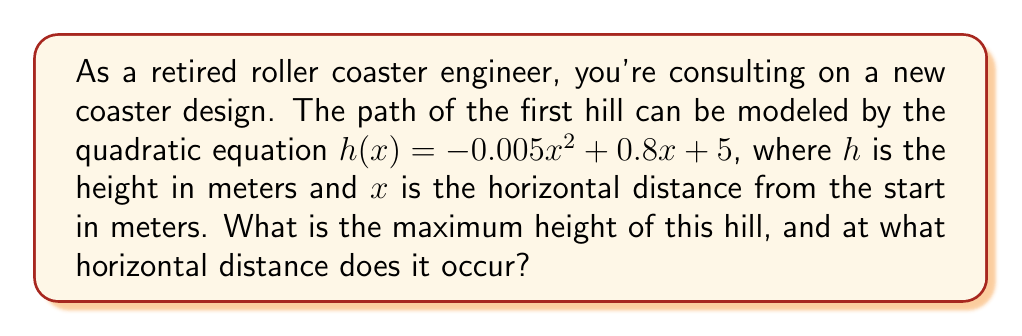Help me with this question. To find the maximum height of the roller coaster hill, we need to follow these steps:

1) The quadratic equation is in the form $h(x) = ax^2 + bx + c$, where:
   $a = -0.005$
   $b = 0.8$
   $c = 5$

2) For a quadratic function, the x-coordinate of the vertex represents the point where the maximum (or minimum) occurs. We can find this using the formula:

   $$x = -\frac{b}{2a}$$

3) Substituting our values:

   $$x = -\frac{0.8}{2(-0.005)} = -\frac{0.8}{-0.01} = 80$$

4) To find the maximum height, we need to calculate $h(80)$:

   $$\begin{align}
   h(80) &= -0.005(80)^2 + 0.8(80) + 5 \\
   &= -0.005(6400) + 64 + 5 \\
   &= -32 + 64 + 5 \\
   &= 37
   \end{align}$$

5) Therefore, the maximum height occurs at a horizontal distance of 80 meters from the start, and the maximum height is 37 meters.
Answer: The maximum height of the roller coaster hill is 37 meters, occurring at a horizontal distance of 80 meters from the start. 